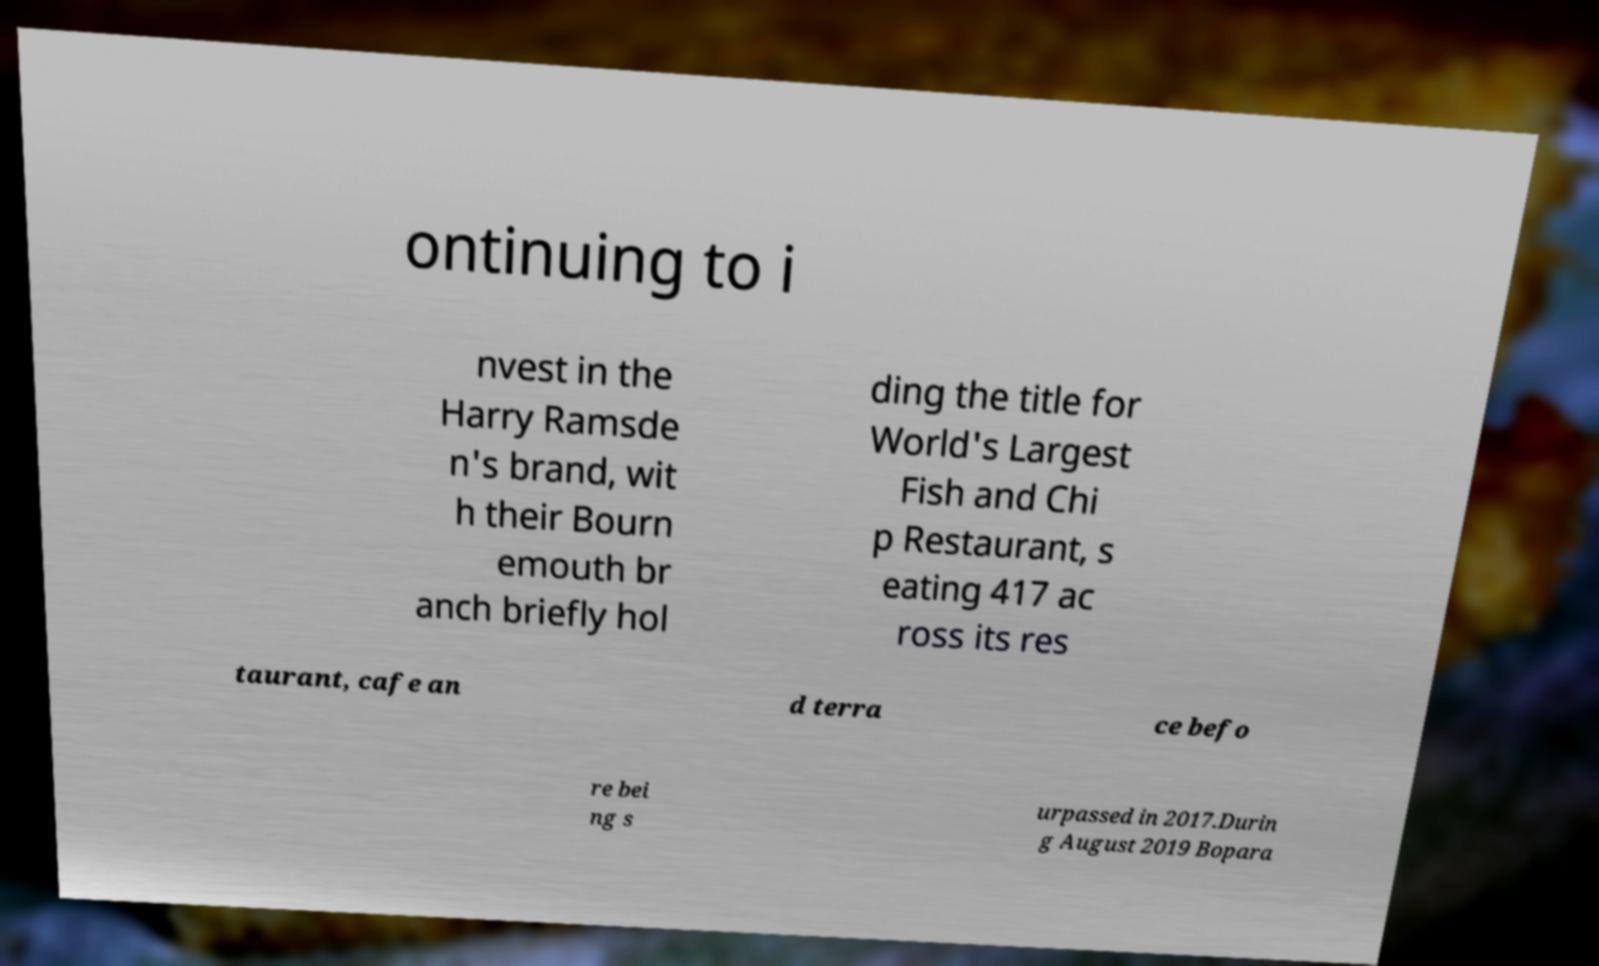Please read and relay the text visible in this image. What does it say? ontinuing to i nvest in the Harry Ramsde n's brand, wit h their Bourn emouth br anch briefly hol ding the title for World's Largest Fish and Chi p Restaurant, s eating 417 ac ross its res taurant, cafe an d terra ce befo re bei ng s urpassed in 2017.Durin g August 2019 Bopara 